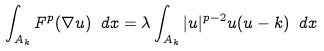Convert formula to latex. <formula><loc_0><loc_0><loc_500><loc_500>\int _ { A _ { k } } F ^ { p } ( \nabla u ) \ d x = \lambda \int _ { A _ { k } } | u | ^ { p - 2 } u ( u - k ) \ d x</formula> 